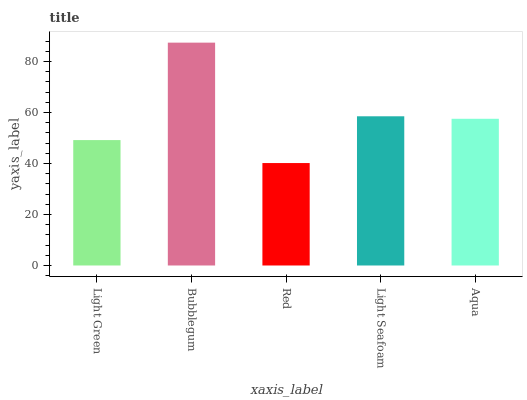Is Red the minimum?
Answer yes or no. Yes. Is Bubblegum the maximum?
Answer yes or no. Yes. Is Bubblegum the minimum?
Answer yes or no. No. Is Red the maximum?
Answer yes or no. No. Is Bubblegum greater than Red?
Answer yes or no. Yes. Is Red less than Bubblegum?
Answer yes or no. Yes. Is Red greater than Bubblegum?
Answer yes or no. No. Is Bubblegum less than Red?
Answer yes or no. No. Is Aqua the high median?
Answer yes or no. Yes. Is Aqua the low median?
Answer yes or no. Yes. Is Red the high median?
Answer yes or no. No. Is Red the low median?
Answer yes or no. No. 